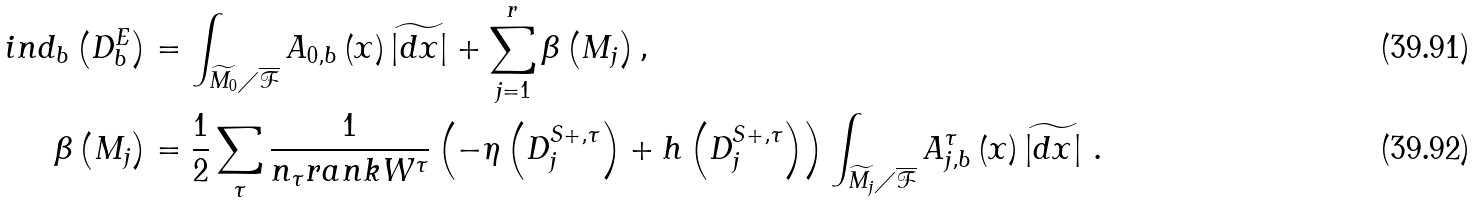<formula> <loc_0><loc_0><loc_500><loc_500>i n d _ { b } \left ( D _ { b } ^ { E } \right ) & = \int _ { \widetilde { M _ { 0 } } \diagup \overline { \mathcal { F } } } A _ { 0 , b } \left ( x \right ) \widetilde { \left | d x \right | } + \sum _ { j = 1 } ^ { r } \beta \left ( M _ { j } \right ) , \\ \beta \left ( M _ { j } \right ) & = \frac { 1 } { 2 } \sum _ { \tau } \frac { 1 } { n _ { \tau } r a n k W ^ { \tau } } \left ( - \eta \left ( D _ { j } ^ { S + , \tau } \right ) + h \left ( D _ { j } ^ { S + , \tau } \right ) \right ) \int _ { \widetilde { M _ { j } } \diagup \overline { \mathcal { F } } } A _ { j , b } ^ { \tau } \left ( x \right ) \widetilde { \left | d x \right | } \ .</formula> 